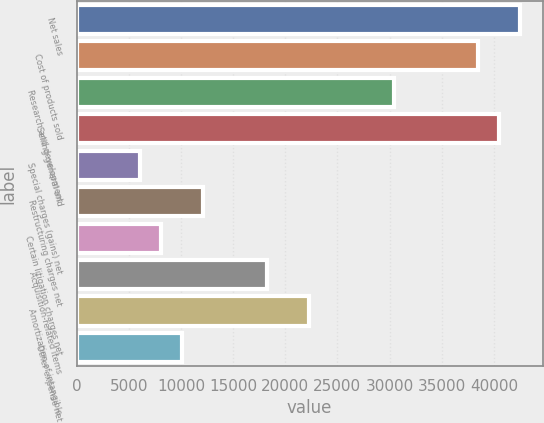Convert chart to OTSL. <chart><loc_0><loc_0><loc_500><loc_500><bar_chart><fcel>Net sales<fcel>Cost of products sold<fcel>Research and development<fcel>Selling general and<fcel>Special charges (gains) net<fcel>Restructuring charges net<fcel>Certain litigation charges net<fcel>Acquisition-related items<fcel>Amortization of intangible<fcel>Other expense net<nl><fcel>42546.8<fcel>38494.8<fcel>30390.9<fcel>40520.8<fcel>6079.16<fcel>12157.1<fcel>8105.14<fcel>18235<fcel>22287<fcel>10131.1<nl></chart> 